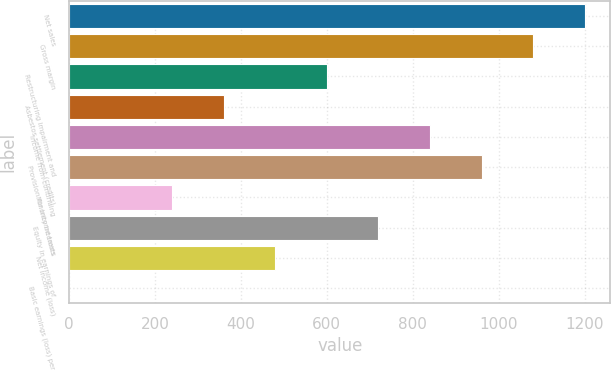<chart> <loc_0><loc_0><loc_500><loc_500><bar_chart><fcel>Net sales<fcel>Gross margin<fcel>Restructuring impairment and<fcel>Asbestos settlement (credits)<fcel>Income from continuing<fcel>Provision for income taxes<fcel>Minority interests<fcel>Equity in earnings of<fcel>Net income (loss)<fcel>Basic earnings (loss) per<nl><fcel>1200.02<fcel>1080.02<fcel>600.02<fcel>360.02<fcel>840.02<fcel>960.02<fcel>240.02<fcel>720.02<fcel>480.02<fcel>0.02<nl></chart> 